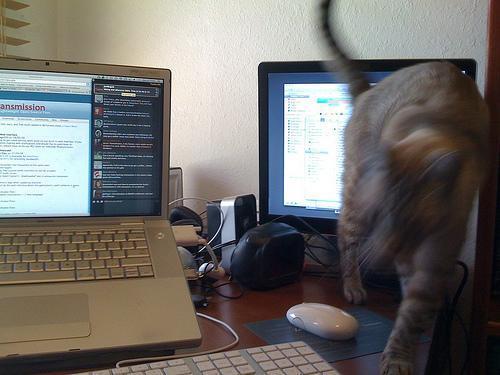How many people are visible?
Give a very brief answer. 0. 